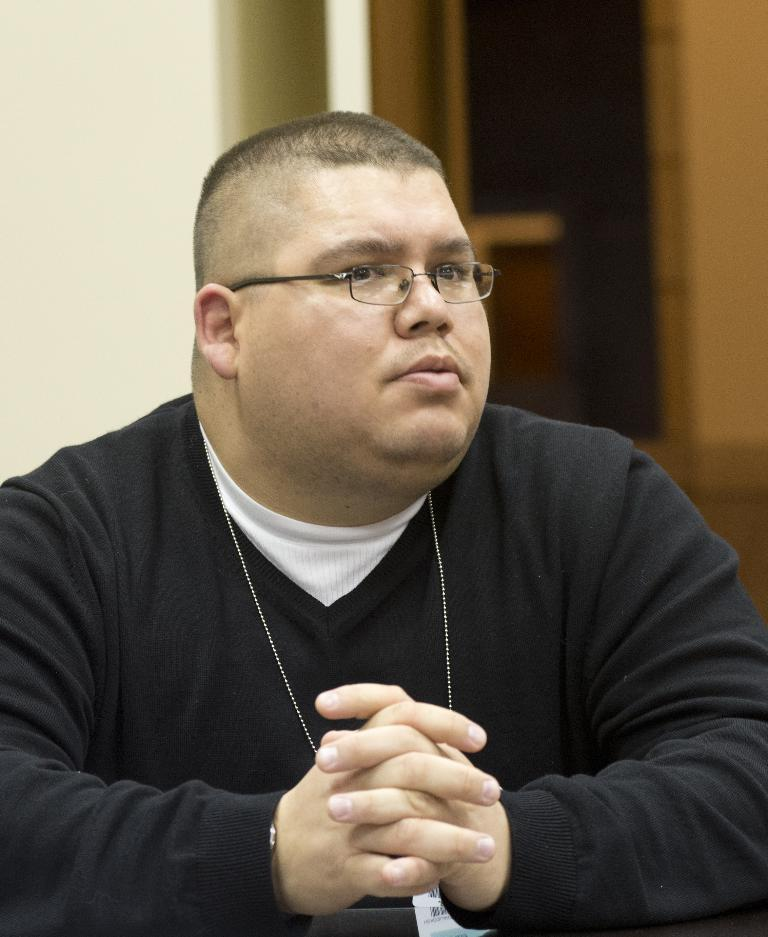Who or what is present in the image? There is a person in the image. Can you describe the person's appearance? The person is wearing spectacles. What can be seen in the background of the image? There is a pole in the background of the image. How many ants are crawling on the person's spectacles in the image? There are no ants present in the image, so it is not possible to determine how many might be crawling on the person's spectacles. 